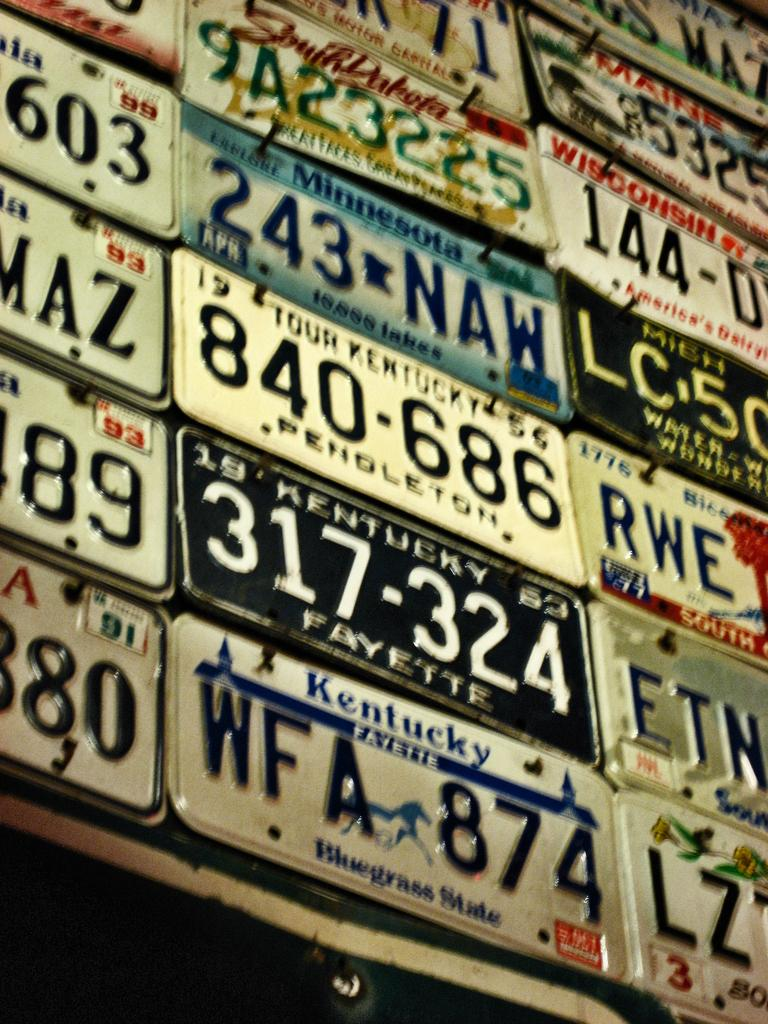What is displayed on the wall in the image? There are number plates on a wall in the image. What information is present on the number plates? The number plates have numbers, text, and pictures on them. What type of twig can be seen growing from the number plates in the image? There is no twig present in the image; the focus is on the number plates with their respective numbers, text, and pictures. 